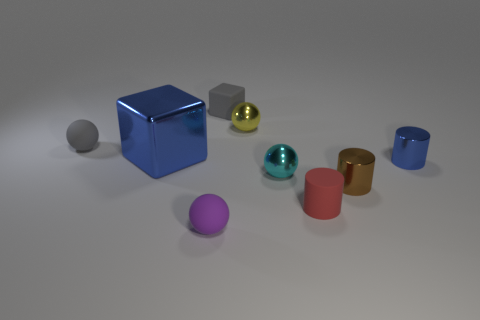Does the small block have the same color as the big thing?
Your answer should be very brief. No. What size is the metallic sphere that is in front of the gray sphere?
Provide a short and direct response. Small. Is the color of the matte sphere behind the small blue metal thing the same as the block behind the large blue metal object?
Your answer should be compact. Yes. What number of other things are there of the same shape as the purple rubber object?
Give a very brief answer. 3. Are there the same number of brown shiny objects that are to the right of the small blue metallic cylinder and yellow metallic objects that are behind the small red rubber thing?
Make the answer very short. No. Does the tiny gray object to the left of the tiny purple sphere have the same material as the block to the left of the gray rubber block?
Your answer should be compact. No. How many other objects are there of the same size as the cyan metal object?
Provide a succinct answer. 7. What number of objects are big blue rubber cylinders or blue metallic things left of the small yellow object?
Your response must be concise. 1. Are there the same number of small brown cylinders behind the tiny gray sphere and small yellow rubber things?
Ensure brevity in your answer.  Yes. What is the shape of the small red object that is the same material as the purple thing?
Ensure brevity in your answer.  Cylinder. 